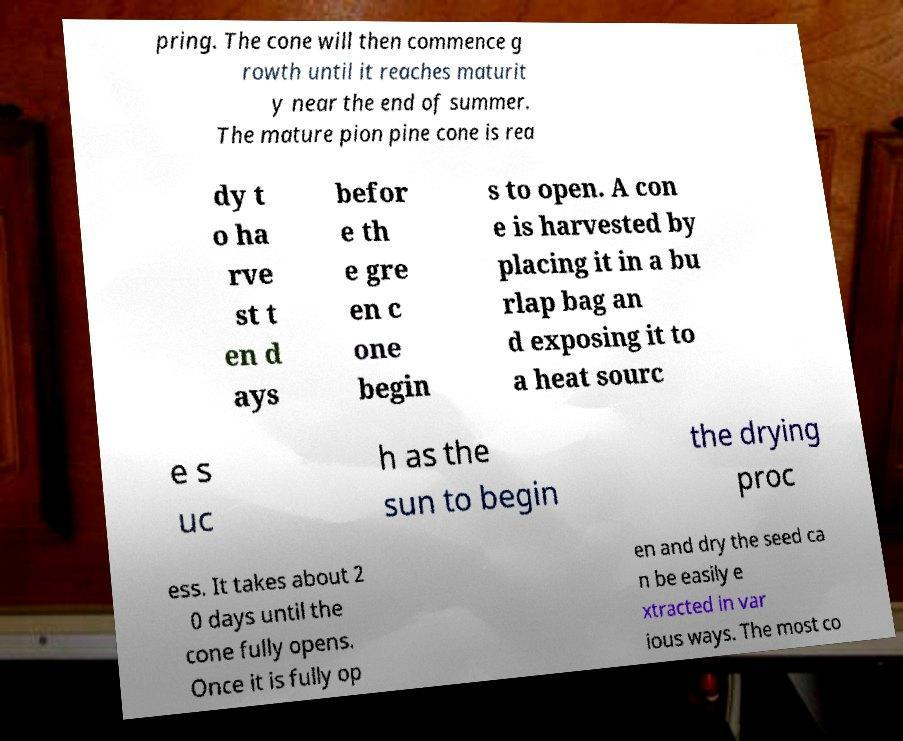For documentation purposes, I need the text within this image transcribed. Could you provide that? pring. The cone will then commence g rowth until it reaches maturit y near the end of summer. The mature pion pine cone is rea dy t o ha rve st t en d ays befor e th e gre en c one begin s to open. A con e is harvested by placing it in a bu rlap bag an d exposing it to a heat sourc e s uc h as the sun to begin the drying proc ess. It takes about 2 0 days until the cone fully opens. Once it is fully op en and dry the seed ca n be easily e xtracted in var ious ways. The most co 